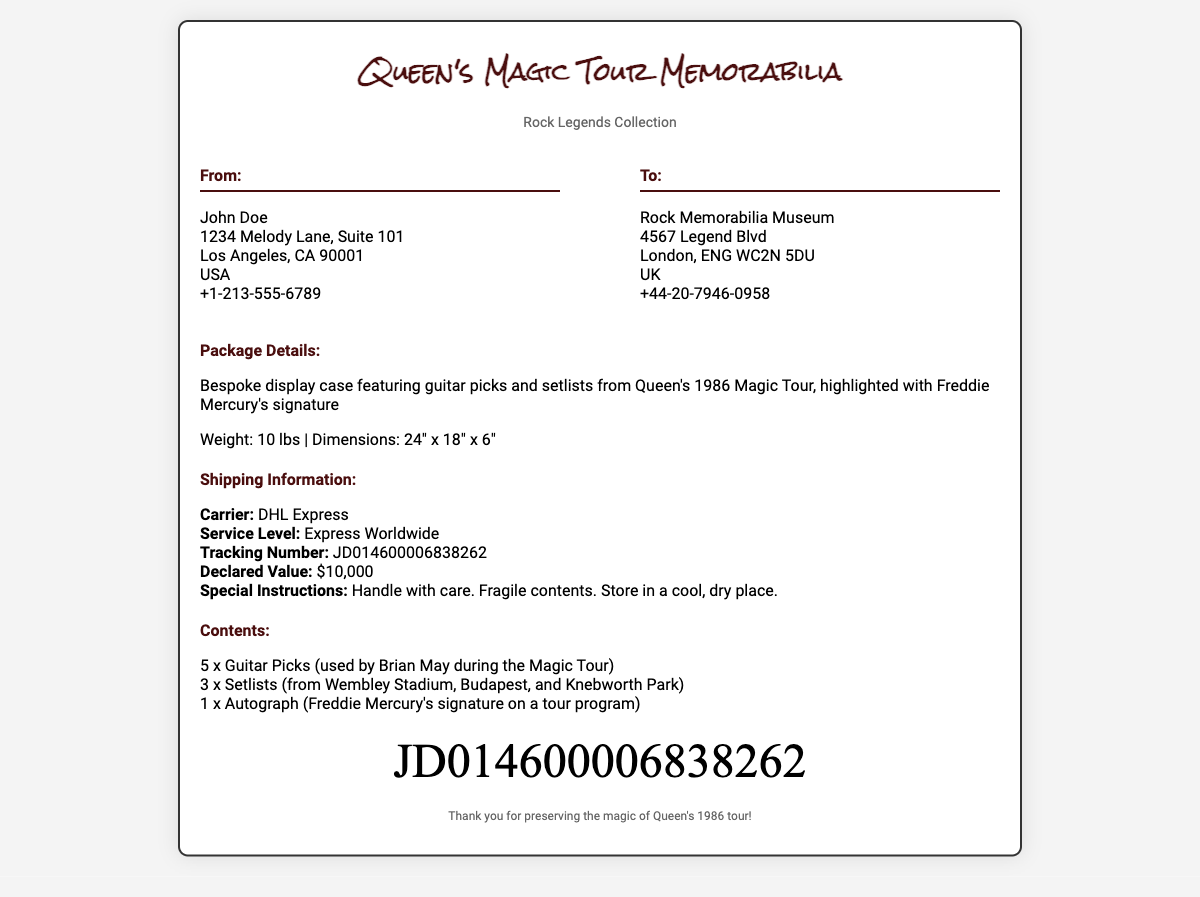What is the title of the collection? The title of the collection is prominently displayed at the top of the document.
Answer: Queen's Magic Tour Memorabilia Who is the sender? The sender's name is listed in the "From" section of the address block.
Answer: John Doe What is the declared value of the package? The declared value is clearly stated in the shipping information section.
Answer: $10,000 How many guitar picks are included? The number of guitar picks is detailed in the contents section.
Answer: 5 What is the weight of the package? The weight is specified in the package details section.
Answer: 10 lbs Why is it important to handle the package with care? Special instructions indicate the fragility of the contents.
Answer: Fragile contents What shipping carrier is used? The name of the shipping carrier is given in the shipping information.
Answer: DHL Express Where is the package being sent? The destination address contains the name of the recipient and location.
Answer: Rock Memorabilia Museum What types of setlists are included in the contents? The specific locations of the setlists can be found in the contents section.
Answer: Wembley Stadium, Budapest, Knebworth Park 